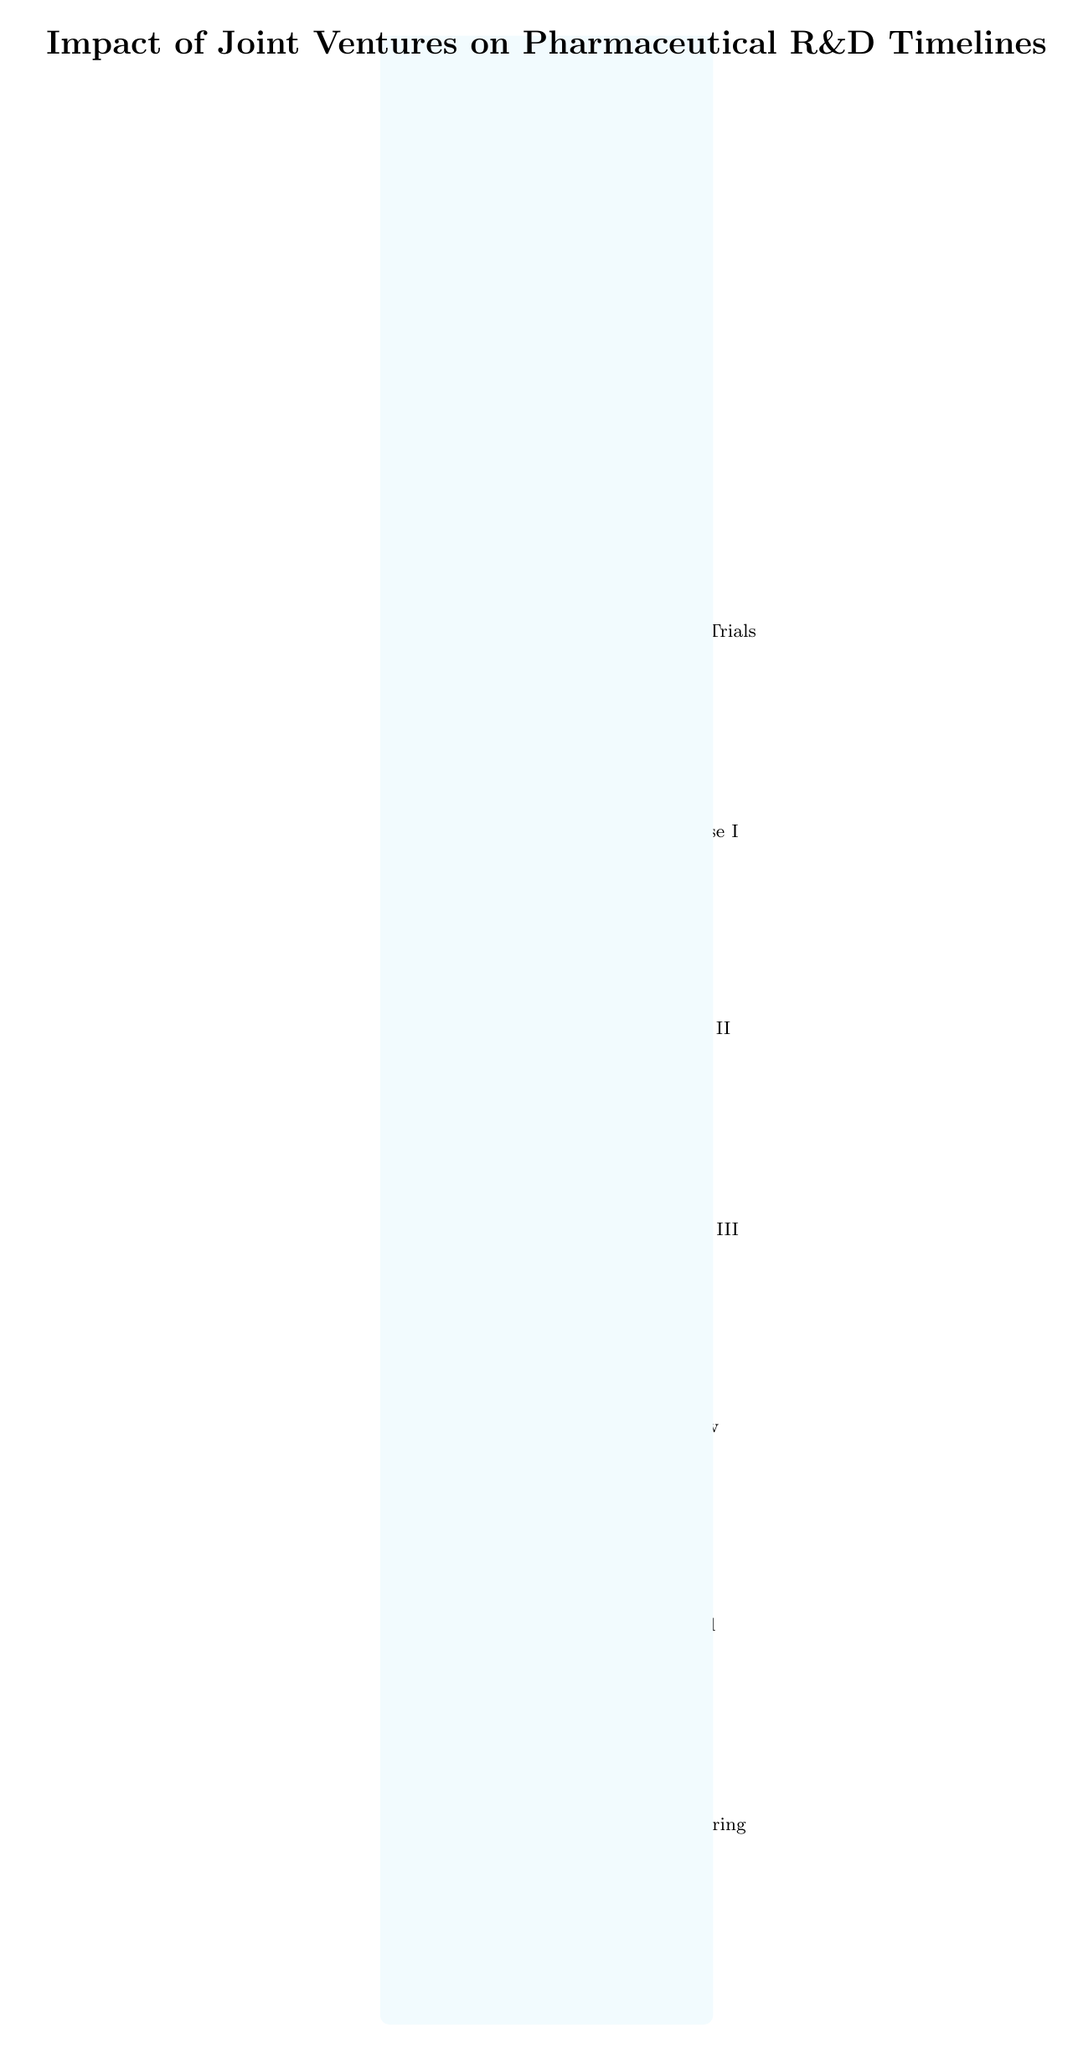What is the first step in the process? The diagram indicates that the first step is "Identify Potential JV Partner," which is the topmost node in the flowchart.
Answer: Identify Potential JV Partner What comes after “JV Formation Agreement”? The step that comes immediately after "JV Formation Agreement" is "R&D Project Kickoff," which is directly below it in the flowchart.
Answer: R&D Project Kickoff How many milestones are there in total from the start to the market launch? The diagram includes ten distinct milestones leading from the initial identification of a joint venture partner to market launch, with each step representing a milestone in the process.
Answer: Ten What milestone follows "Phase I Clinical Trials"? According to the flow of the diagram, the milestone that follows "Phase I Clinical Trials" is "Phase II Clinical Trials," which is directly below it.
Answer: Phase II Clinical Trials What action occurs after "Regulatory Submission"? The action that follows "Regulatory Submission" is "Market Launch." This is the subsequent node after the regulatory process is complete.
Answer: Market Launch What does the arrow between "Preclinical Trials" and "Phase I Clinical Trials" represent? The arrow indicates a transition, labeled as "Transition to Phase I," signifying the move from the preclinical stage to the first phase of clinical trials.
Answer: Transition to Phase I What is the final step of the process? The last step in the diagram is "Post-Market Surveillance," which is the terminal point at the bottom of the flowchart.
Answer: Post-Market Surveillance Which milestone has a focus on “Continued Monitoring”? The focus on “Continued Monitoring” corresponds to the last milestone, "Post-Market Surveillance," indicating ongoing observation after the market launch.
Answer: Post-Market Surveillance 